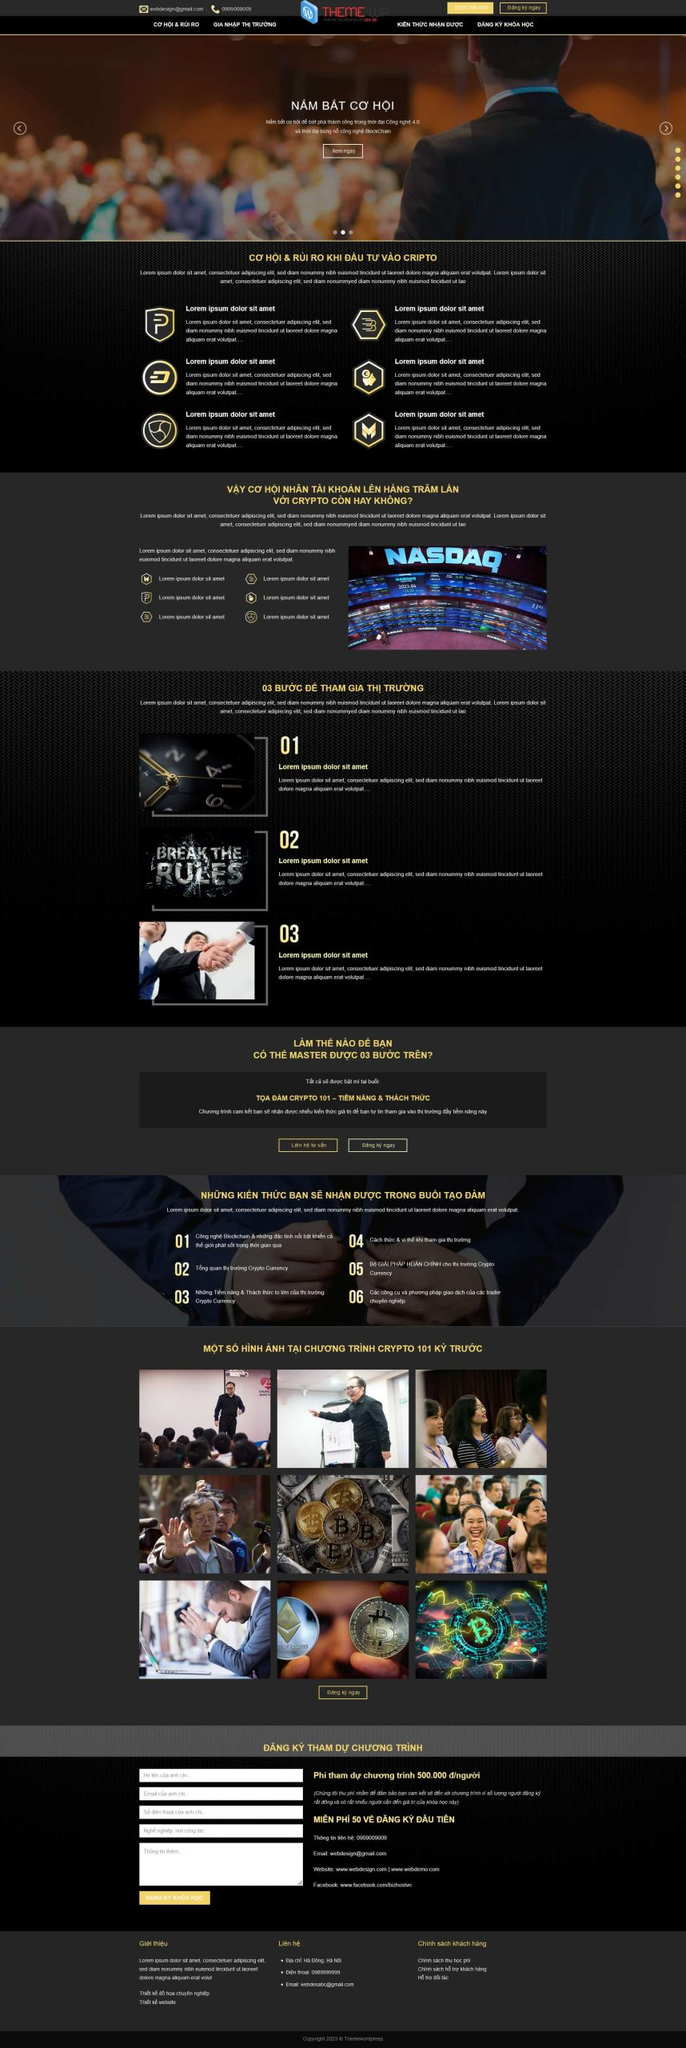Liệt kê 5 ngành nghề, lĩnh vực phù hợp với website này, phân cách các màu sắc bằng dấu phẩy. Chỉ trả về kết quả, phân cách bằng dấy phẩy
 Đầu tư tài chính, Kinh doanh tiền mã hóa, Công nghệ Blockchain, Tư vấn tài chính, Đào tạo đầu tư 